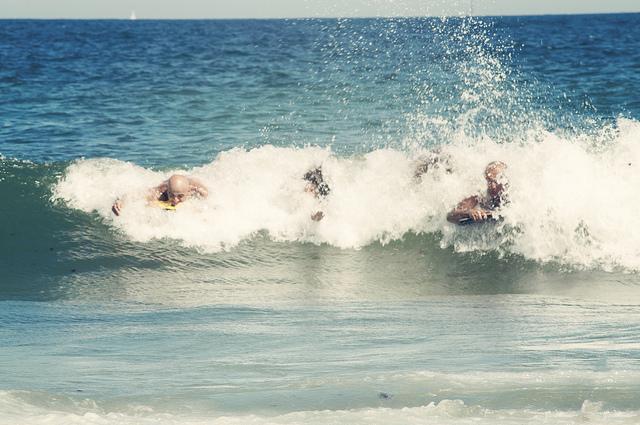Is the water cold?
Concise answer only. No. Do these people look like they are struggling to swim?
Answer briefly. No. Is a wave hitting the people?
Answer briefly. Yes. Overcast or sunny?
Quick response, please. Sunny. Why are the people lying on their boards instead of standing on them?
Be succinct. Waiting for wave. What is the person doing?
Short answer required. Surfing. How many humans in this scene?
Give a very brief answer. 3. 